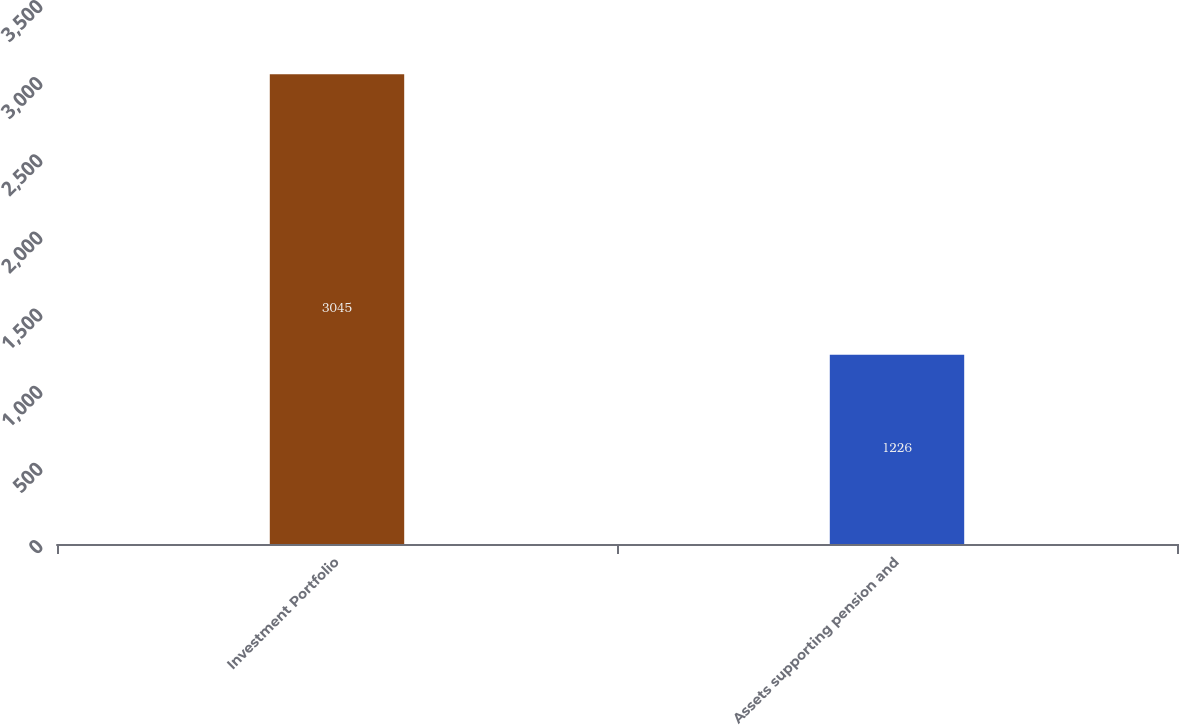Convert chart. <chart><loc_0><loc_0><loc_500><loc_500><bar_chart><fcel>Investment Portfolio<fcel>Assets supporting pension and<nl><fcel>3045<fcel>1226<nl></chart> 